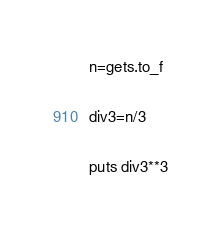<code> <loc_0><loc_0><loc_500><loc_500><_Ruby_>n=gets.to_f

div3=n/3

puts div3**3</code> 